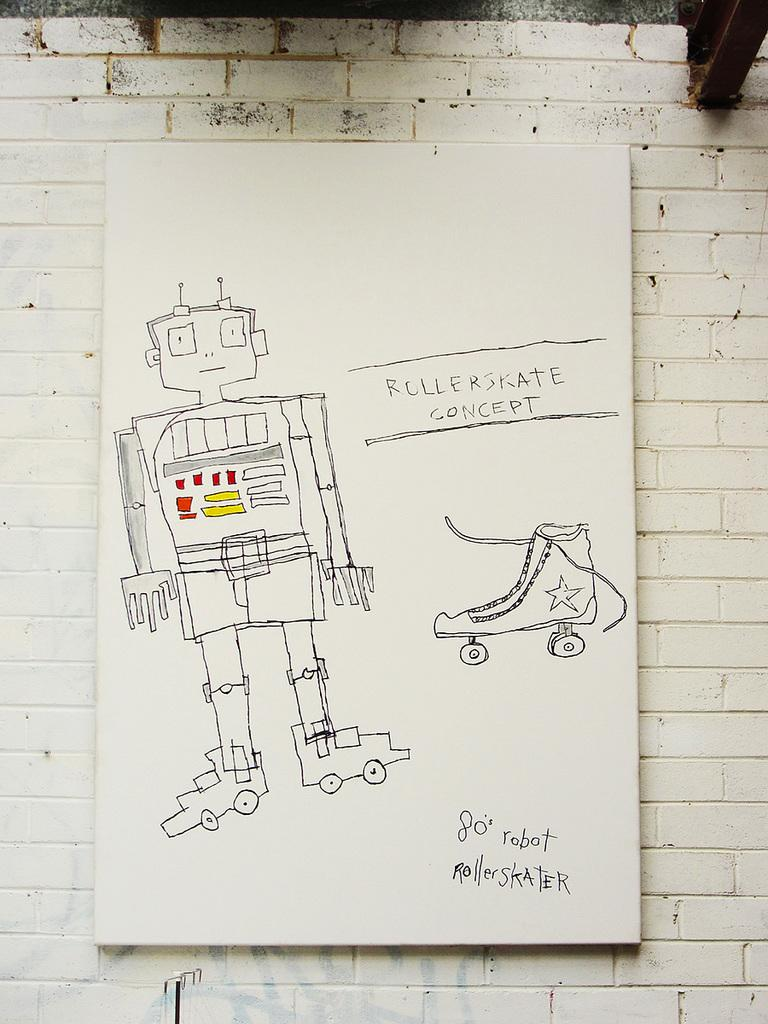What type of art is depicted in the image? There are sketch arts of a robot and a skating shoe in the image. Can you describe the subjects of the sketch arts? One sketch art features a robot, and the other sketch art features a skating shoe. What is present on the wall in the image? There is text on the wall in the image. What is the condition of the base of the robot in the image? There is no base of a robot present in the image, as it is a sketch art of a robot and not a physical robot. 